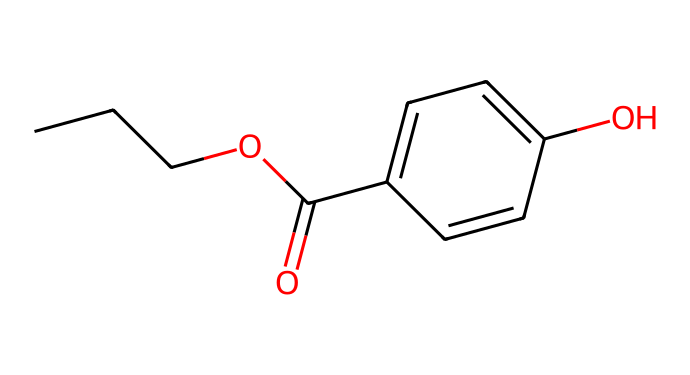What is the total number of carbon atoms in propylparaben? By analyzing the SMILES representation, we count the carbon atoms represented as 'C'. There are a total of 9 carbon atoms.
Answer: 9 How many oxygen atoms are present in this compound? In the SMILES representation, the presence of 'O' indicates the oxygen atoms. There are 2 oxygen atoms in propylparaben.
Answer: 2 What functional group is responsible for the preservative properties of propylparaben? The presence of the ester functional group (shown by -COO-) is key to its use as a preservative, allowing it to inhibit the growth of mold and bacteria.
Answer: ester Which part of the structure indicates that propylparaben has antioxidant properties? The hydroxyl group (-OH) attached to the aromatic ring allows for the potential to donate hydrogen atoms, which contributes to its antioxidant properties.
Answer: hydroxyl group What type of chemical compound does propylparaben belong to? Given that propylparaben is commonly used as a preservative, it is classified as a paraben, which is a type of antimicrobial agent.
Answer: paraben What is the molecular weight of propylparaben? By summing the atomic weights based on the counts from the SMILES structure (C, H, and O), we find its molecular weight to be approximately 180.2 g/mol.
Answer: 180.2 g/mol Which part of the structure suggests that propylparaben may be lipophilic? The long hydrocarbon chain (propyl group) contributes to the lipophilic nature of propylparaben, allowing it to interact with lipid membranes.
Answer: propyl group 